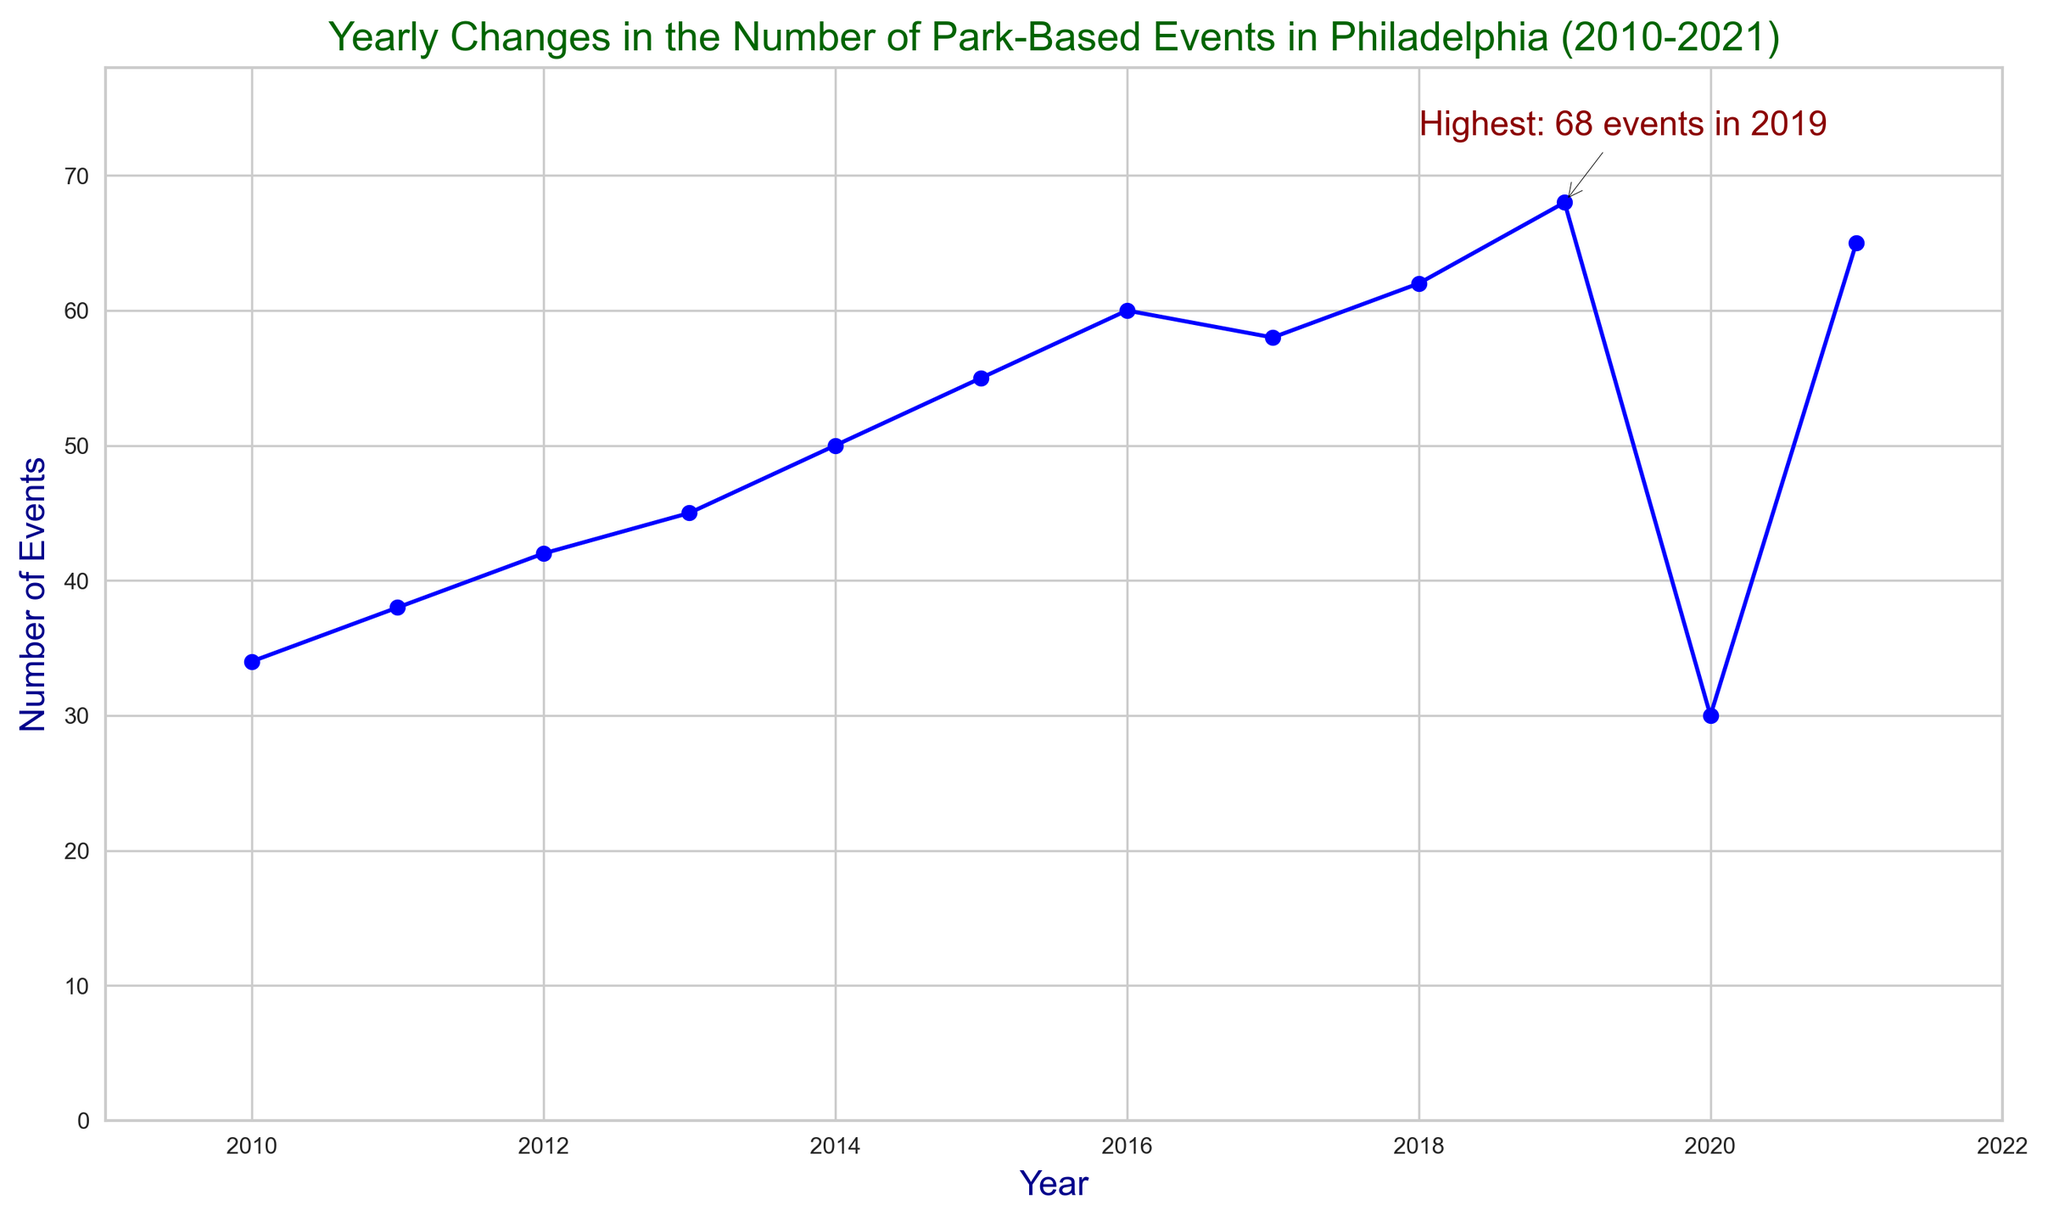What's the overall trend in the number of park-based events in Philadelphia from 2010 to 2021? The overall trend can be observed by looking at the line connecting the points from 2010 to 2021. The line mostly goes upward with some fluctuations, indicating an increase in the number of events over the years, with a noticeable dip around 2020.
Answer: Increasing In which year did the highest number of park-based events occur, and how many events were there? The annotation on the chart highlights the year with the highest number of events. According to the annotation, the highest number of events is indicated as "Highest: 68 events in 2019."
Answer: 2019, 68 How does the number of park-based events in 2020 compare to 2019? By comparing the points for the years 2019 and 2020, it is evident that the number of events in 2020 is significantly lower than in 2019. This can be seen from the sudden drop in the line on the chart in 2020.
Answer: Lower What is the average number of park-based events from 2010 to 2021? To find the average, add the number of events for each year and divide by the total number of years: (34 + 38 + 42 + 45 + 50 + 55 + 60 + 58 + 62 + 68 + 30 + 65) / 12 = 607 / 12 = 50.58.
Answer: 50.58 What was the longest period during which the number of park-based events consistently increased year over year? Examine the chart to find the longest stretch of consecutive years where the number of events increased each year. From 2010 to 2016, the line consistently moves upward each year without any dips: 2010 to 2016 is six years.
Answer: Six years Which year saw the sharpest increase in the number of park-based events compared to the previous year, and by how much? By looking at the steepness of the slopes between consecutive years, the increase from 2018 (62 events) to 2019 (68 events) appears to be the sharpest. The difference is 68 - 62 = 6 events.
Answer: 2019, 6 events What could have caused a noticeable drop in the number of park-based events in 2020? The chart shows a significant decline in the number of events in 2020. This is likely due to external factors such as the COVID-19 pandemic, which led to lockdowns and restrictions on public gatherings.
Answer: COVID-19 pandemic How many years had more than 50 park-based events? Identify the years where the number of events is greater than 50 by inspecting the chart. The years 2014, 2015, 2016, 2017, 2018, 2019, and 2021 all had more than 50 events. That amounts to 7 years.
Answer: 7 years Which color is used to depict the data line, and what might be a reason for choosing this color? The color of the data line is blue. Blue is often used in charts for its visual clarity and contrast against the background, making the data points and trends easy to follow.
Answer: Blue 